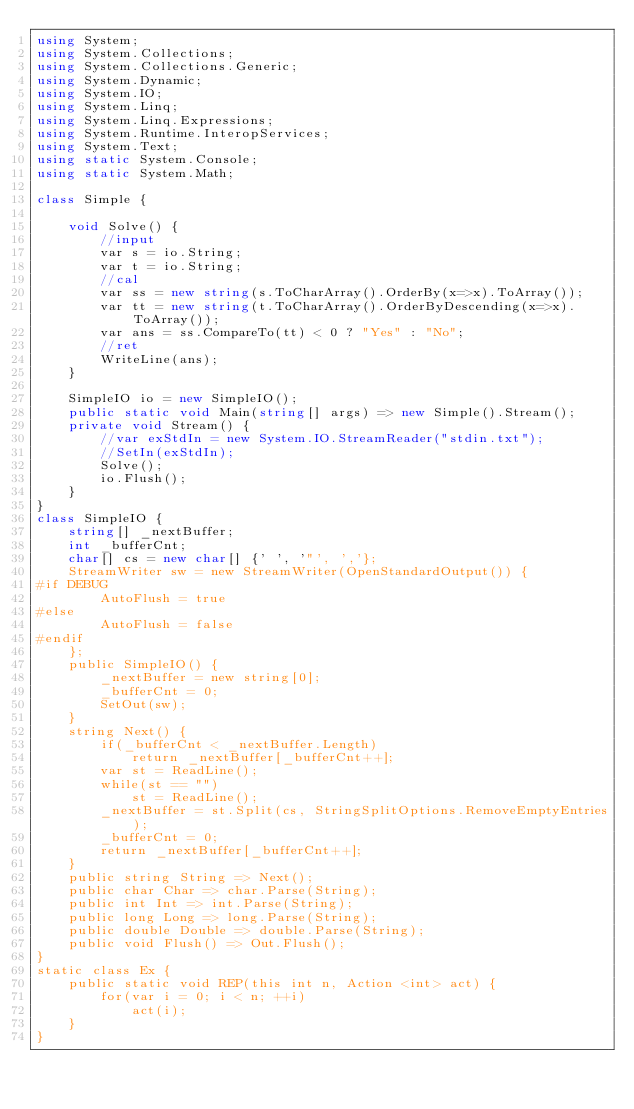Convert code to text. <code><loc_0><loc_0><loc_500><loc_500><_C#_>using System;
using System.Collections;
using System.Collections.Generic;
using System.Dynamic;
using System.IO;
using System.Linq;
using System.Linq.Expressions;
using System.Runtime.InteropServices;
using System.Text;
using static System.Console;
using static System.Math;

class Simple {    
    
    void Solve() {
        //input        
        var s = io.String;
        var t = io.String;
        //cal
        var ss = new string(s.ToCharArray().OrderBy(x=>x).ToArray());
        var tt = new string(t.ToCharArray().OrderByDescending(x=>x).ToArray());
        var ans = ss.CompareTo(tt) < 0 ? "Yes" : "No";
        //ret
        WriteLine(ans);        
    }

    SimpleIO io = new SimpleIO();
    public static void Main(string[] args) => new Simple().Stream();
    private void Stream() {
        //var exStdIn = new System.IO.StreamReader("stdin.txt");
        //SetIn(exStdIn);
        Solve();
        io.Flush();        
    }
}
class SimpleIO {
    string[] _nextBuffer;
    int _bufferCnt;
    char[] cs = new char[] {' ', '"', ','};
    StreamWriter sw = new StreamWriter(OpenStandardOutput()) {
#if DEBUG
        AutoFlush = true
#else
        AutoFlush = false
#endif
    };
    public SimpleIO() {
        _nextBuffer = new string[0];
        _bufferCnt = 0;
        SetOut(sw);        
    }
    string Next() {
        if(_bufferCnt < _nextBuffer.Length)
            return _nextBuffer[_bufferCnt++];
        var st = ReadLine();
        while(st == "")
            st = ReadLine();
        _nextBuffer = st.Split(cs, StringSplitOptions.RemoveEmptyEntries);
        _bufferCnt = 0;
        return _nextBuffer[_bufferCnt++];
    }
    public string String => Next();
    public char Char => char.Parse(String);
    public int Int => int.Parse(String);
    public long Long => long.Parse(String);
    public double Double => double.Parse(String);
    public void Flush() => Out.Flush();
}
static class Ex {
    public static void REP(this int n, Action <int> act) {
        for(var i = 0; i < n; ++i) 
            act(i);
    }
}</code> 